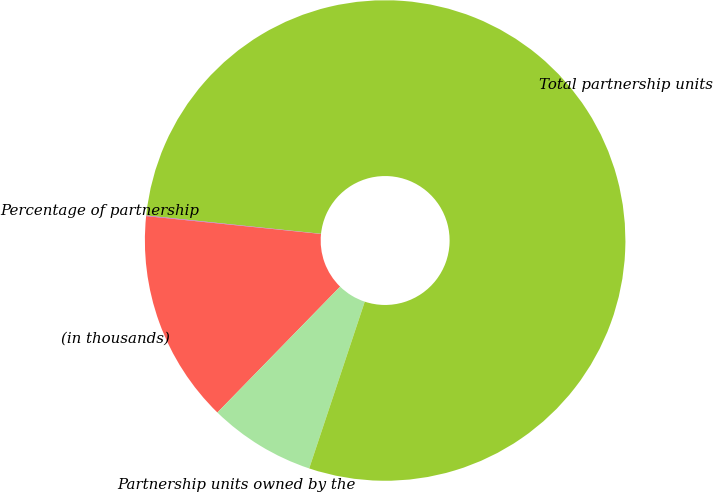Convert chart. <chart><loc_0><loc_0><loc_500><loc_500><pie_chart><fcel>(in thousands)<fcel>Partnership units owned by the<fcel>Total partnership units<fcel>Percentage of partnership<nl><fcel>14.32%<fcel>7.18%<fcel>78.45%<fcel>0.04%<nl></chart> 